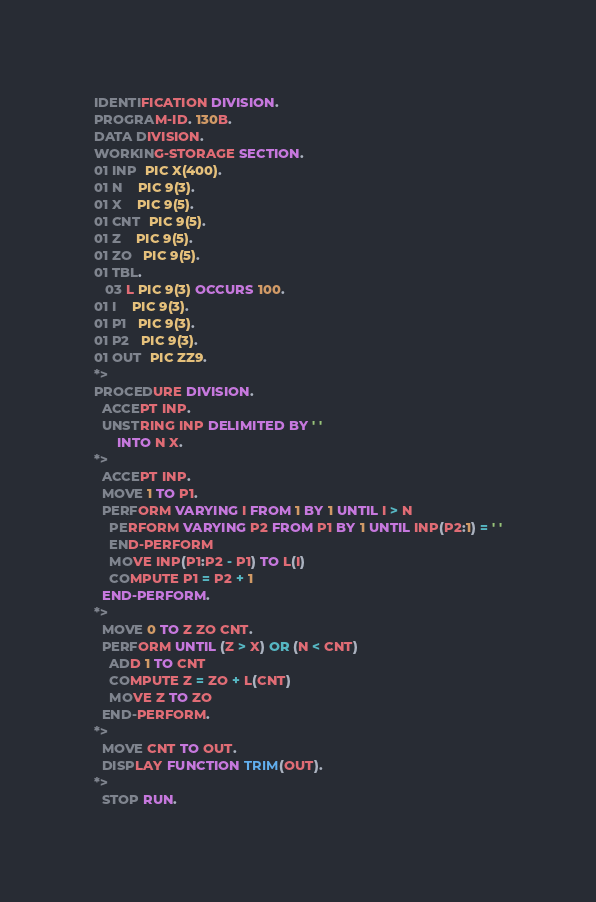Convert code to text. <code><loc_0><loc_0><loc_500><loc_500><_COBOL_>IDENTIFICATION DIVISION.
PROGRAM-ID. 130B.
DATA DIVISION.
WORKING-STORAGE SECTION.
01 INP  PIC X(400).
01 N    PIC 9(3).
01 X    PIC 9(5).
01 CNT  PIC 9(5). 
01 Z    PIC 9(5).
01 ZO   PIC 9(5).
01 TBL.
   03 L PIC 9(3) OCCURS 100.
01 I    PIC 9(3).
01 P1   PIC 9(3).
01 P2   PIC 9(3). 
01 OUT  PIC ZZ9.
*>
PROCEDURE DIVISION.
  ACCEPT INP.
  UNSTRING INP DELIMITED BY ' '
      INTO N X.
*>
  ACCEPT INP.
  MOVE 1 TO P1.
  PERFORM VARYING I FROM 1 BY 1 UNTIL I > N
    PERFORM VARYING P2 FROM P1 BY 1 UNTIL INP(P2:1) = ' '
    END-PERFORM
    MOVE INP(P1:P2 - P1) TO L(I)
    COMPUTE P1 = P2 + 1
  END-PERFORM.  
*>
  MOVE 0 TO Z ZO CNT.
  PERFORM UNTIL (Z > X) OR (N < CNT)
    ADD 1 TO CNT
    COMPUTE Z = ZO + L(CNT)
    MOVE Z TO ZO
  END-PERFORM.  
*>
  MOVE CNT TO OUT.
  DISPLAY FUNCTION TRIM(OUT).
*>
  STOP RUN.
</code> 